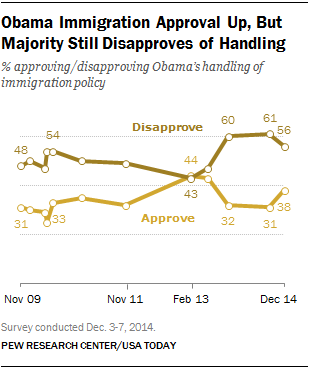Give some essential details in this illustration. At what point in time does the difference between the approval and disapproval rates equal 1%, based on 44,240 data points? The leftmost value in the lower line as shown in the graph is 31. 